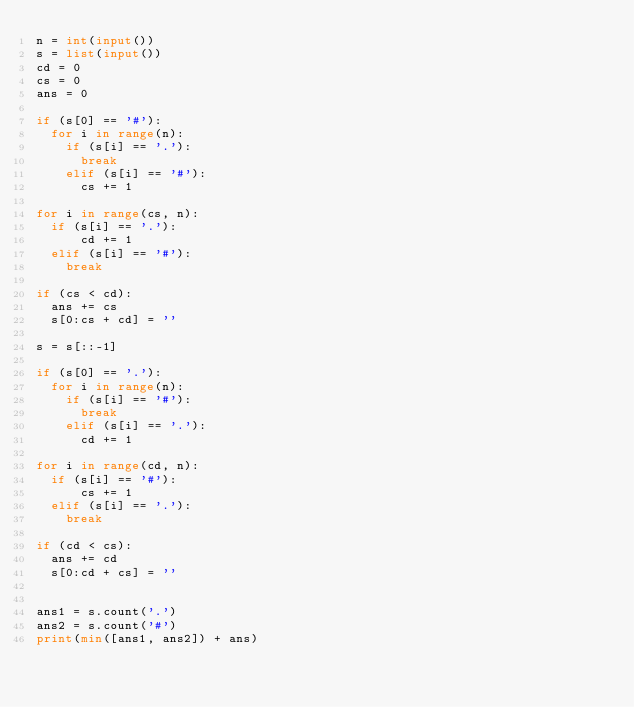<code> <loc_0><loc_0><loc_500><loc_500><_Python_>n = int(input())
s = list(input())
cd = 0
cs = 0
ans = 0

if (s[0] == '#'):
  for i in range(n):
    if (s[i] == '.'):
      break
    elif (s[i] == '#'):
      cs += 1

for i in range(cs, n):
  if (s[i] == '.'):
      cd += 1
  elif (s[i] == '#'):
    break

if (cs < cd):
  ans += cs
  s[0:cs + cd] = ''

s = s[::-1]

if (s[0] == '.'):
  for i in range(n):
    if (s[i] == '#'):
      break
    elif (s[i] == '.'):
      cd += 1

for i in range(cd, n):
  if (s[i] == '#'):
      cs += 1
  elif (s[i] == '.'):
    break

if (cd < cs):
  ans += cd
  s[0:cd + cs] = ''


ans1 = s.count('.')
ans2 = s.count('#')
print(min([ans1, ans2]) + ans)
</code> 